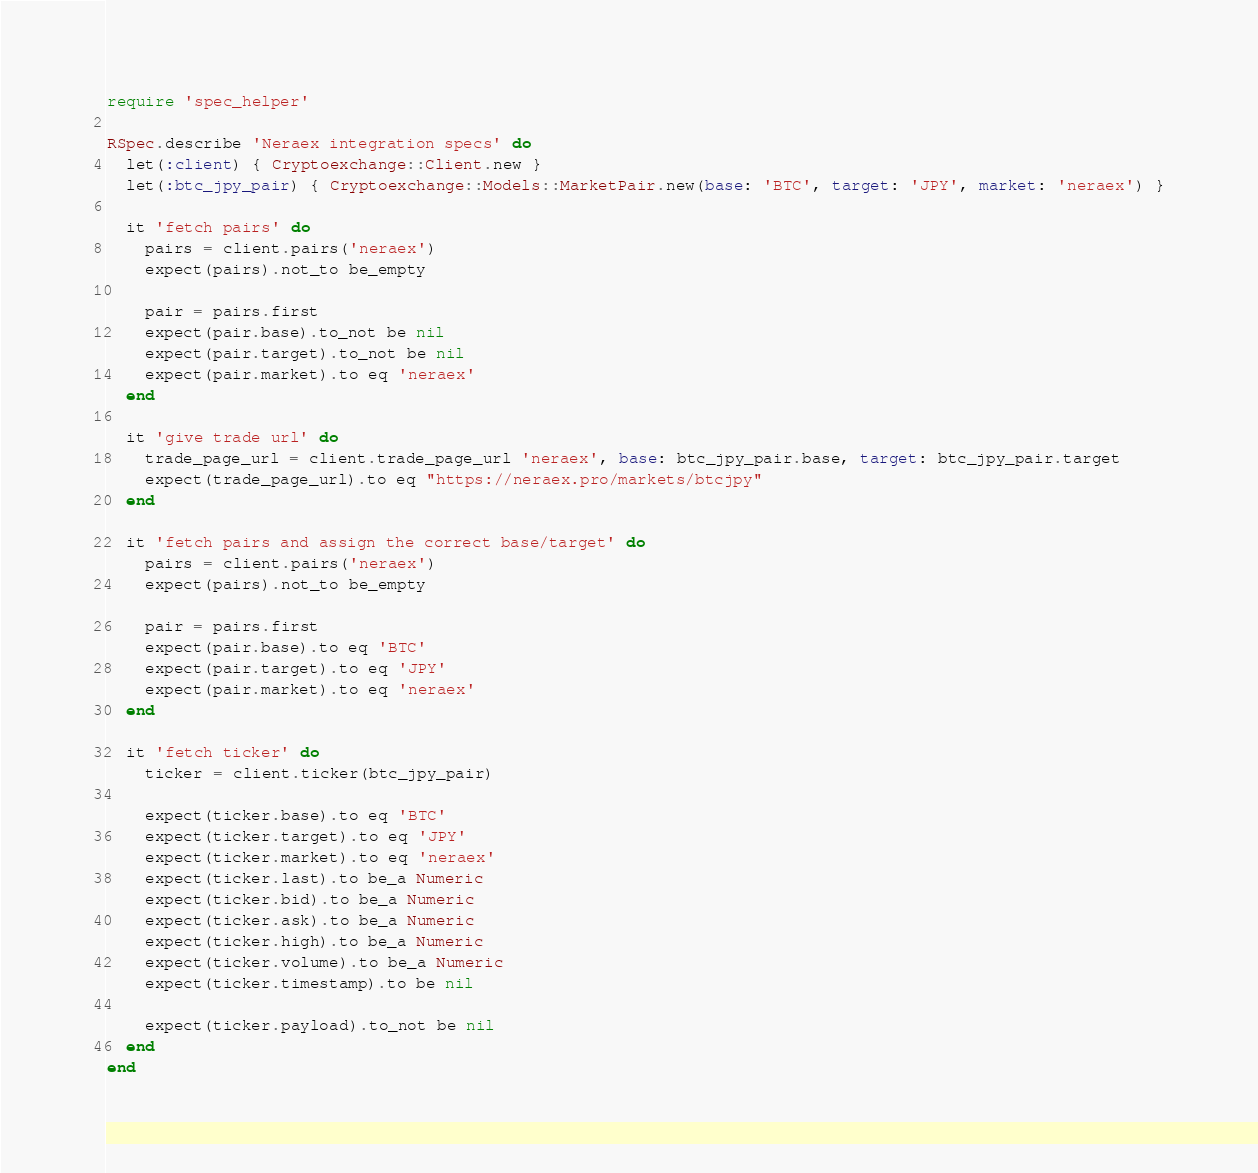Convert code to text. <code><loc_0><loc_0><loc_500><loc_500><_Ruby_>require 'spec_helper'

RSpec.describe 'Neraex integration specs' do
  let(:client) { Cryptoexchange::Client.new }
  let(:btc_jpy_pair) { Cryptoexchange::Models::MarketPair.new(base: 'BTC', target: 'JPY', market: 'neraex') }

  it 'fetch pairs' do
    pairs = client.pairs('neraex')
    expect(pairs).not_to be_empty

    pair = pairs.first
    expect(pair.base).to_not be nil
    expect(pair.target).to_not be nil
    expect(pair.market).to eq 'neraex'
  end

  it 'give trade url' do
    trade_page_url = client.trade_page_url 'neraex', base: btc_jpy_pair.base, target: btc_jpy_pair.target
    expect(trade_page_url).to eq "https://neraex.pro/markets/btcjpy"
  end

  it 'fetch pairs and assign the correct base/target' do
    pairs = client.pairs('neraex')
    expect(pairs).not_to be_empty

    pair = pairs.first
    expect(pair.base).to eq 'BTC'
    expect(pair.target).to eq 'JPY'
    expect(pair.market).to eq 'neraex'
  end

  it 'fetch ticker' do
    ticker = client.ticker(btc_jpy_pair)

    expect(ticker.base).to eq 'BTC'
    expect(ticker.target).to eq 'JPY'
    expect(ticker.market).to eq 'neraex'
    expect(ticker.last).to be_a Numeric
    expect(ticker.bid).to be_a Numeric
    expect(ticker.ask).to be_a Numeric
    expect(ticker.high).to be_a Numeric
    expect(ticker.volume).to be_a Numeric
    expect(ticker.timestamp).to be nil
    
    expect(ticker.payload).to_not be nil
  end
end
</code> 